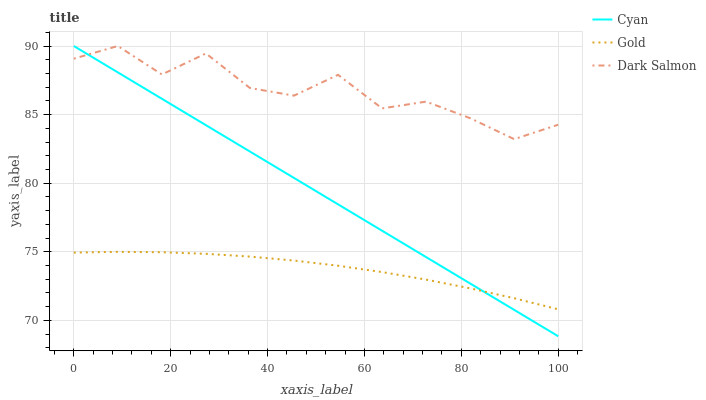Does Gold have the minimum area under the curve?
Answer yes or no. Yes. Does Dark Salmon have the maximum area under the curve?
Answer yes or no. Yes. Does Dark Salmon have the minimum area under the curve?
Answer yes or no. No. Does Gold have the maximum area under the curve?
Answer yes or no. No. Is Cyan the smoothest?
Answer yes or no. Yes. Is Dark Salmon the roughest?
Answer yes or no. Yes. Is Gold the smoothest?
Answer yes or no. No. Is Gold the roughest?
Answer yes or no. No. Does Cyan have the lowest value?
Answer yes or no. Yes. Does Gold have the lowest value?
Answer yes or no. No. Does Dark Salmon have the highest value?
Answer yes or no. Yes. Does Gold have the highest value?
Answer yes or no. No. Is Gold less than Dark Salmon?
Answer yes or no. Yes. Is Dark Salmon greater than Gold?
Answer yes or no. Yes. Does Dark Salmon intersect Cyan?
Answer yes or no. Yes. Is Dark Salmon less than Cyan?
Answer yes or no. No. Is Dark Salmon greater than Cyan?
Answer yes or no. No. Does Gold intersect Dark Salmon?
Answer yes or no. No. 